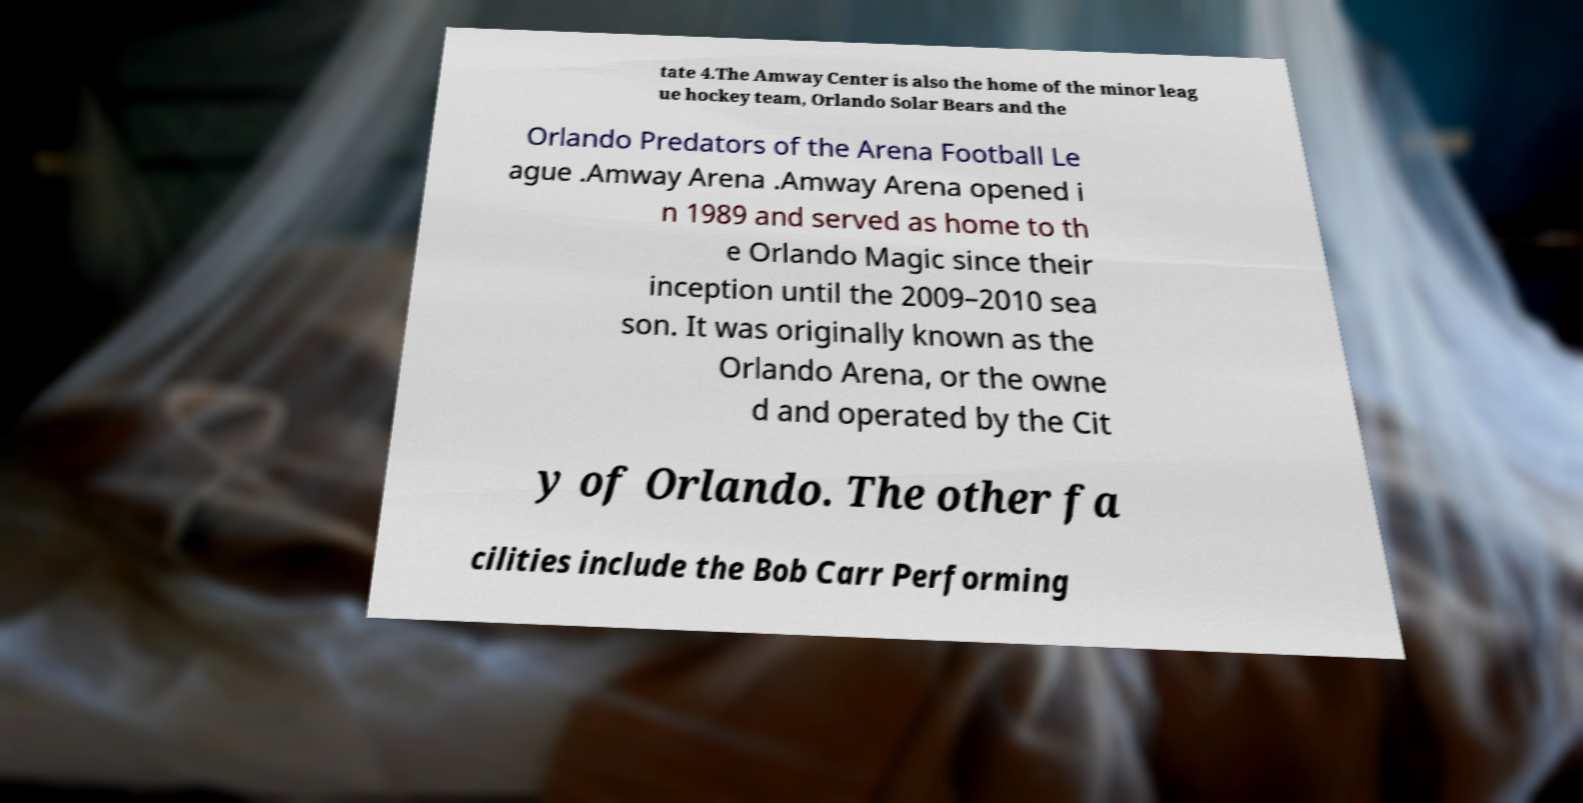There's text embedded in this image that I need extracted. Can you transcribe it verbatim? tate 4.The Amway Center is also the home of the minor leag ue hockey team, Orlando Solar Bears and the Orlando Predators of the Arena Football Le ague .Amway Arena .Amway Arena opened i n 1989 and served as home to th e Orlando Magic since their inception until the 2009–2010 sea son. It was originally known as the Orlando Arena, or the owne d and operated by the Cit y of Orlando. The other fa cilities include the Bob Carr Performing 